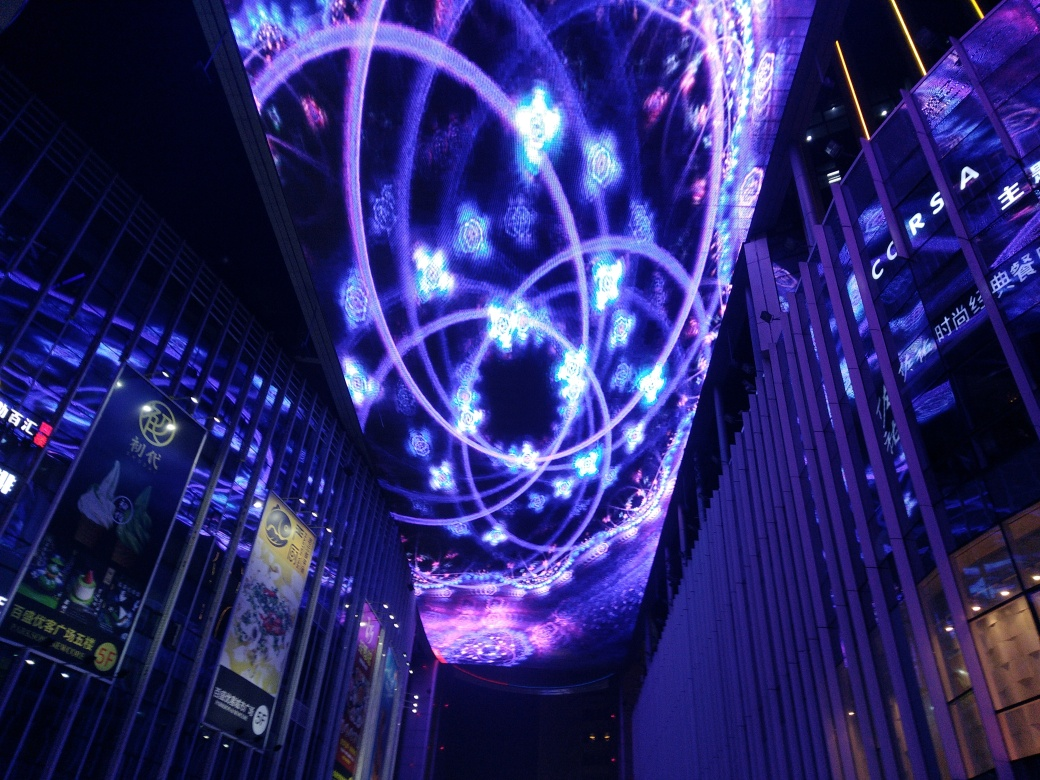Is the lighting fairly sufficient in the image? Yes, the lighting is more than sufficient in the image. The vivid colors and brilliant illumination from the displayed patterns and designs create a bright and enchanting atmosphere. The neon glow and dynamic visuals seen clearly against the night sky indicate an efficient use of light in this scene. 